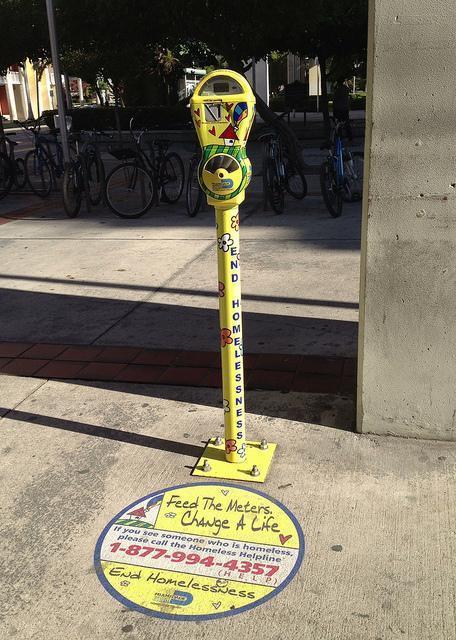How many bicycles can be seen?
Give a very brief answer. 5. How many of the motorcycles are blue?
Give a very brief answer. 0. 